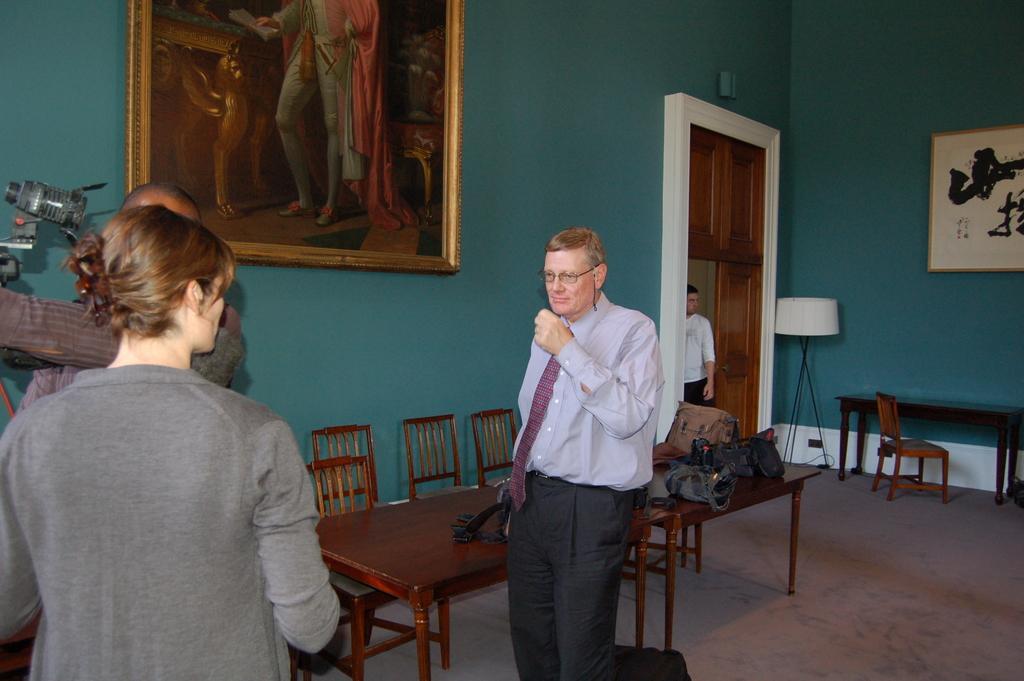In one or two sentences, can you explain what this image depicts? In this image some person are standing on the floor the room has table,chairs,photos,posters,table lamps and bags are there in the background is cloudy. 